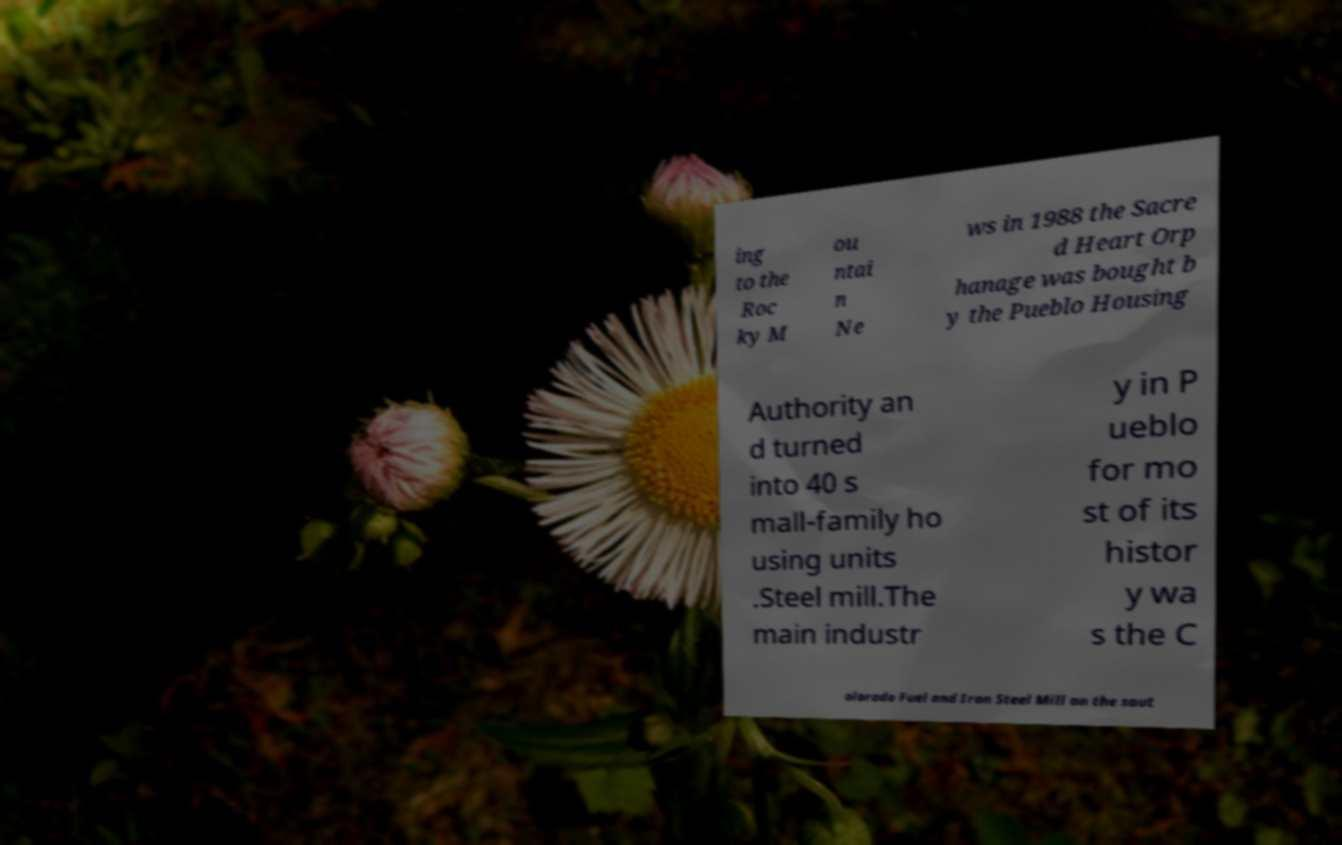There's text embedded in this image that I need extracted. Can you transcribe it verbatim? ing to the Roc ky M ou ntai n Ne ws in 1988 the Sacre d Heart Orp hanage was bought b y the Pueblo Housing Authority an d turned into 40 s mall-family ho using units .Steel mill.The main industr y in P ueblo for mo st of its histor y wa s the C olorado Fuel and Iron Steel Mill on the sout 